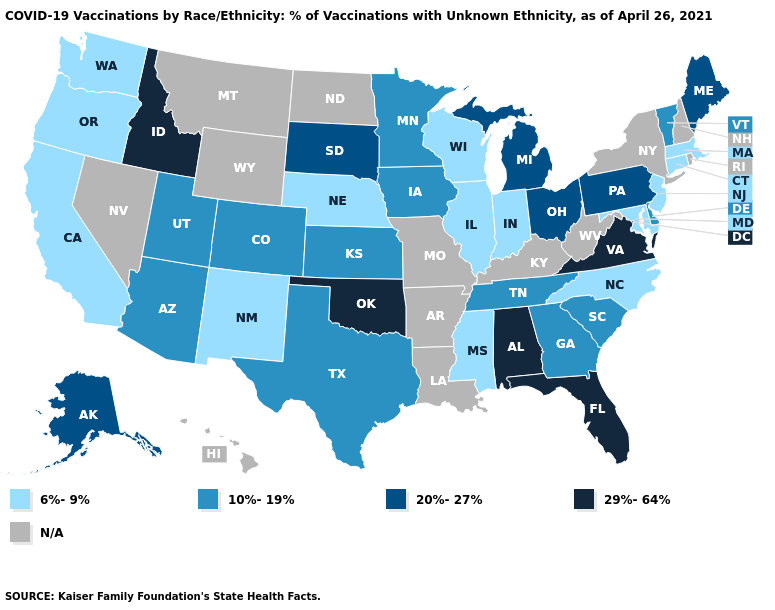What is the lowest value in the West?
Write a very short answer. 6%-9%. What is the value of Oregon?
Short answer required. 6%-9%. Does the first symbol in the legend represent the smallest category?
Answer briefly. Yes. Which states hav the highest value in the MidWest?
Give a very brief answer. Michigan, Ohio, South Dakota. Which states have the highest value in the USA?
Short answer required. Alabama, Florida, Idaho, Oklahoma, Virginia. Among the states that border Wyoming , which have the lowest value?
Quick response, please. Nebraska. What is the value of California?
Write a very short answer. 6%-9%. Which states have the lowest value in the South?
Be succinct. Maryland, Mississippi, North Carolina. Name the states that have a value in the range 6%-9%?
Concise answer only. California, Connecticut, Illinois, Indiana, Maryland, Massachusetts, Mississippi, Nebraska, New Jersey, New Mexico, North Carolina, Oregon, Washington, Wisconsin. Does Alaska have the lowest value in the USA?
Quick response, please. No. Which states have the lowest value in the South?
Concise answer only. Maryland, Mississippi, North Carolina. Does Nebraska have the highest value in the MidWest?
Give a very brief answer. No. Among the states that border Oklahoma , which have the lowest value?
Answer briefly. New Mexico. 